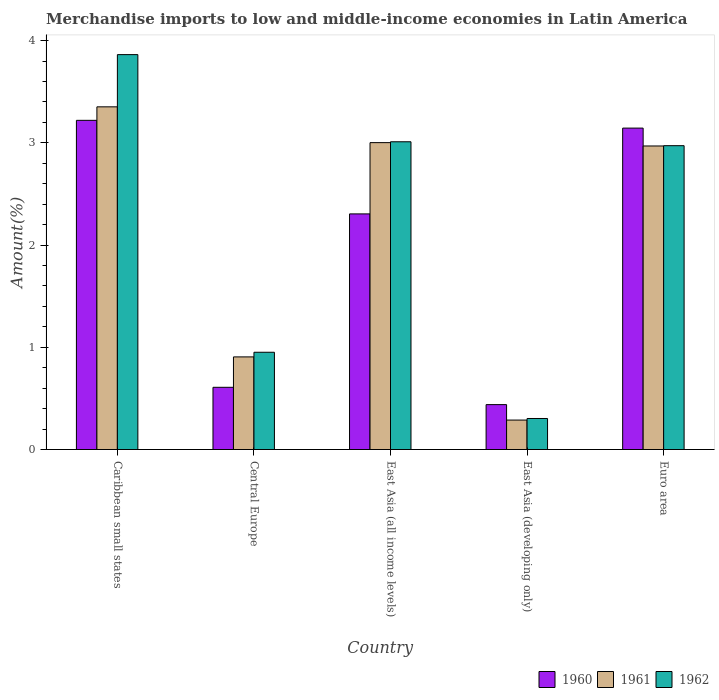How many groups of bars are there?
Keep it short and to the point. 5. Are the number of bars on each tick of the X-axis equal?
Your answer should be compact. Yes. In how many cases, is the number of bars for a given country not equal to the number of legend labels?
Your answer should be compact. 0. What is the percentage of amount earned from merchandise imports in 1962 in East Asia (all income levels)?
Offer a terse response. 3.01. Across all countries, what is the maximum percentage of amount earned from merchandise imports in 1962?
Ensure brevity in your answer.  3.86. Across all countries, what is the minimum percentage of amount earned from merchandise imports in 1960?
Provide a short and direct response. 0.44. In which country was the percentage of amount earned from merchandise imports in 1961 maximum?
Keep it short and to the point. Caribbean small states. In which country was the percentage of amount earned from merchandise imports in 1960 minimum?
Your answer should be compact. East Asia (developing only). What is the total percentage of amount earned from merchandise imports in 1960 in the graph?
Provide a short and direct response. 9.72. What is the difference between the percentage of amount earned from merchandise imports in 1960 in Central Europe and that in East Asia (all income levels)?
Offer a terse response. -1.7. What is the difference between the percentage of amount earned from merchandise imports in 1962 in Central Europe and the percentage of amount earned from merchandise imports in 1961 in Caribbean small states?
Provide a short and direct response. -2.4. What is the average percentage of amount earned from merchandise imports in 1960 per country?
Offer a very short reply. 1.94. What is the difference between the percentage of amount earned from merchandise imports of/in 1962 and percentage of amount earned from merchandise imports of/in 1961 in Central Europe?
Your response must be concise. 0.05. In how many countries, is the percentage of amount earned from merchandise imports in 1960 greater than 2.2 %?
Your response must be concise. 3. What is the ratio of the percentage of amount earned from merchandise imports in 1960 in Central Europe to that in East Asia (all income levels)?
Provide a succinct answer. 0.26. What is the difference between the highest and the second highest percentage of amount earned from merchandise imports in 1962?
Offer a terse response. 0.04. What is the difference between the highest and the lowest percentage of amount earned from merchandise imports in 1960?
Provide a short and direct response. 2.78. Is the sum of the percentage of amount earned from merchandise imports in 1962 in Caribbean small states and East Asia (all income levels) greater than the maximum percentage of amount earned from merchandise imports in 1961 across all countries?
Offer a very short reply. Yes. What does the 3rd bar from the right in Central Europe represents?
Give a very brief answer. 1960. Is it the case that in every country, the sum of the percentage of amount earned from merchandise imports in 1961 and percentage of amount earned from merchandise imports in 1962 is greater than the percentage of amount earned from merchandise imports in 1960?
Your answer should be compact. Yes. How many bars are there?
Offer a terse response. 15. Are all the bars in the graph horizontal?
Your response must be concise. No. How many countries are there in the graph?
Your answer should be very brief. 5. What is the difference between two consecutive major ticks on the Y-axis?
Provide a succinct answer. 1. Are the values on the major ticks of Y-axis written in scientific E-notation?
Provide a short and direct response. No. Does the graph contain any zero values?
Ensure brevity in your answer.  No. Does the graph contain grids?
Make the answer very short. No. What is the title of the graph?
Ensure brevity in your answer.  Merchandise imports to low and middle-income economies in Latin America. Does "1976" appear as one of the legend labels in the graph?
Make the answer very short. No. What is the label or title of the X-axis?
Give a very brief answer. Country. What is the label or title of the Y-axis?
Your answer should be very brief. Amount(%). What is the Amount(%) in 1960 in Caribbean small states?
Make the answer very short. 3.22. What is the Amount(%) in 1961 in Caribbean small states?
Offer a very short reply. 3.35. What is the Amount(%) in 1962 in Caribbean small states?
Your answer should be very brief. 3.86. What is the Amount(%) in 1960 in Central Europe?
Provide a succinct answer. 0.61. What is the Amount(%) of 1961 in Central Europe?
Give a very brief answer. 0.91. What is the Amount(%) of 1962 in Central Europe?
Your response must be concise. 0.95. What is the Amount(%) of 1960 in East Asia (all income levels)?
Provide a short and direct response. 2.31. What is the Amount(%) of 1961 in East Asia (all income levels)?
Your answer should be very brief. 3. What is the Amount(%) in 1962 in East Asia (all income levels)?
Your answer should be very brief. 3.01. What is the Amount(%) of 1960 in East Asia (developing only)?
Give a very brief answer. 0.44. What is the Amount(%) of 1961 in East Asia (developing only)?
Give a very brief answer. 0.29. What is the Amount(%) of 1962 in East Asia (developing only)?
Your answer should be compact. 0.3. What is the Amount(%) in 1960 in Euro area?
Offer a very short reply. 3.14. What is the Amount(%) in 1961 in Euro area?
Your answer should be compact. 2.97. What is the Amount(%) in 1962 in Euro area?
Give a very brief answer. 2.97. Across all countries, what is the maximum Amount(%) in 1960?
Give a very brief answer. 3.22. Across all countries, what is the maximum Amount(%) in 1961?
Your answer should be very brief. 3.35. Across all countries, what is the maximum Amount(%) of 1962?
Your response must be concise. 3.86. Across all countries, what is the minimum Amount(%) in 1960?
Provide a succinct answer. 0.44. Across all countries, what is the minimum Amount(%) in 1961?
Ensure brevity in your answer.  0.29. Across all countries, what is the minimum Amount(%) of 1962?
Provide a short and direct response. 0.3. What is the total Amount(%) in 1960 in the graph?
Ensure brevity in your answer.  9.72. What is the total Amount(%) of 1961 in the graph?
Offer a terse response. 10.52. What is the total Amount(%) of 1962 in the graph?
Give a very brief answer. 11.1. What is the difference between the Amount(%) in 1960 in Caribbean small states and that in Central Europe?
Keep it short and to the point. 2.61. What is the difference between the Amount(%) of 1961 in Caribbean small states and that in Central Europe?
Your answer should be very brief. 2.45. What is the difference between the Amount(%) of 1962 in Caribbean small states and that in Central Europe?
Your answer should be compact. 2.91. What is the difference between the Amount(%) in 1960 in Caribbean small states and that in East Asia (all income levels)?
Keep it short and to the point. 0.92. What is the difference between the Amount(%) in 1961 in Caribbean small states and that in East Asia (all income levels)?
Make the answer very short. 0.35. What is the difference between the Amount(%) of 1962 in Caribbean small states and that in East Asia (all income levels)?
Your answer should be compact. 0.85. What is the difference between the Amount(%) of 1960 in Caribbean small states and that in East Asia (developing only)?
Make the answer very short. 2.78. What is the difference between the Amount(%) of 1961 in Caribbean small states and that in East Asia (developing only)?
Provide a succinct answer. 3.06. What is the difference between the Amount(%) of 1962 in Caribbean small states and that in East Asia (developing only)?
Ensure brevity in your answer.  3.56. What is the difference between the Amount(%) of 1960 in Caribbean small states and that in Euro area?
Give a very brief answer. 0.08. What is the difference between the Amount(%) in 1961 in Caribbean small states and that in Euro area?
Your response must be concise. 0.38. What is the difference between the Amount(%) of 1962 in Caribbean small states and that in Euro area?
Keep it short and to the point. 0.89. What is the difference between the Amount(%) of 1960 in Central Europe and that in East Asia (all income levels)?
Provide a succinct answer. -1.7. What is the difference between the Amount(%) of 1961 in Central Europe and that in East Asia (all income levels)?
Make the answer very short. -2.1. What is the difference between the Amount(%) of 1962 in Central Europe and that in East Asia (all income levels)?
Make the answer very short. -2.06. What is the difference between the Amount(%) in 1960 in Central Europe and that in East Asia (developing only)?
Give a very brief answer. 0.17. What is the difference between the Amount(%) in 1961 in Central Europe and that in East Asia (developing only)?
Your answer should be compact. 0.62. What is the difference between the Amount(%) in 1962 in Central Europe and that in East Asia (developing only)?
Ensure brevity in your answer.  0.65. What is the difference between the Amount(%) in 1960 in Central Europe and that in Euro area?
Give a very brief answer. -2.54. What is the difference between the Amount(%) of 1961 in Central Europe and that in Euro area?
Offer a terse response. -2.06. What is the difference between the Amount(%) of 1962 in Central Europe and that in Euro area?
Offer a terse response. -2.02. What is the difference between the Amount(%) in 1960 in East Asia (all income levels) and that in East Asia (developing only)?
Offer a terse response. 1.87. What is the difference between the Amount(%) of 1961 in East Asia (all income levels) and that in East Asia (developing only)?
Your answer should be very brief. 2.71. What is the difference between the Amount(%) in 1962 in East Asia (all income levels) and that in East Asia (developing only)?
Your answer should be compact. 2.71. What is the difference between the Amount(%) of 1960 in East Asia (all income levels) and that in Euro area?
Your answer should be very brief. -0.84. What is the difference between the Amount(%) of 1961 in East Asia (all income levels) and that in Euro area?
Provide a short and direct response. 0.03. What is the difference between the Amount(%) of 1962 in East Asia (all income levels) and that in Euro area?
Your response must be concise. 0.04. What is the difference between the Amount(%) in 1960 in East Asia (developing only) and that in Euro area?
Your answer should be compact. -2.71. What is the difference between the Amount(%) of 1961 in East Asia (developing only) and that in Euro area?
Keep it short and to the point. -2.68. What is the difference between the Amount(%) of 1962 in East Asia (developing only) and that in Euro area?
Give a very brief answer. -2.67. What is the difference between the Amount(%) of 1960 in Caribbean small states and the Amount(%) of 1961 in Central Europe?
Make the answer very short. 2.31. What is the difference between the Amount(%) of 1960 in Caribbean small states and the Amount(%) of 1962 in Central Europe?
Provide a succinct answer. 2.27. What is the difference between the Amount(%) in 1961 in Caribbean small states and the Amount(%) in 1962 in Central Europe?
Offer a very short reply. 2.4. What is the difference between the Amount(%) in 1960 in Caribbean small states and the Amount(%) in 1961 in East Asia (all income levels)?
Your answer should be very brief. 0.22. What is the difference between the Amount(%) of 1960 in Caribbean small states and the Amount(%) of 1962 in East Asia (all income levels)?
Give a very brief answer. 0.21. What is the difference between the Amount(%) of 1961 in Caribbean small states and the Amount(%) of 1962 in East Asia (all income levels)?
Provide a succinct answer. 0.34. What is the difference between the Amount(%) of 1960 in Caribbean small states and the Amount(%) of 1961 in East Asia (developing only)?
Provide a short and direct response. 2.93. What is the difference between the Amount(%) in 1960 in Caribbean small states and the Amount(%) in 1962 in East Asia (developing only)?
Provide a short and direct response. 2.92. What is the difference between the Amount(%) of 1961 in Caribbean small states and the Amount(%) of 1962 in East Asia (developing only)?
Provide a short and direct response. 3.05. What is the difference between the Amount(%) of 1960 in Caribbean small states and the Amount(%) of 1961 in Euro area?
Ensure brevity in your answer.  0.25. What is the difference between the Amount(%) of 1960 in Caribbean small states and the Amount(%) of 1962 in Euro area?
Ensure brevity in your answer.  0.25. What is the difference between the Amount(%) of 1961 in Caribbean small states and the Amount(%) of 1962 in Euro area?
Make the answer very short. 0.38. What is the difference between the Amount(%) of 1960 in Central Europe and the Amount(%) of 1961 in East Asia (all income levels)?
Ensure brevity in your answer.  -2.39. What is the difference between the Amount(%) in 1960 in Central Europe and the Amount(%) in 1962 in East Asia (all income levels)?
Ensure brevity in your answer.  -2.4. What is the difference between the Amount(%) in 1961 in Central Europe and the Amount(%) in 1962 in East Asia (all income levels)?
Offer a very short reply. -2.1. What is the difference between the Amount(%) in 1960 in Central Europe and the Amount(%) in 1961 in East Asia (developing only)?
Offer a very short reply. 0.32. What is the difference between the Amount(%) in 1960 in Central Europe and the Amount(%) in 1962 in East Asia (developing only)?
Keep it short and to the point. 0.31. What is the difference between the Amount(%) of 1961 in Central Europe and the Amount(%) of 1962 in East Asia (developing only)?
Offer a terse response. 0.6. What is the difference between the Amount(%) of 1960 in Central Europe and the Amount(%) of 1961 in Euro area?
Offer a terse response. -2.36. What is the difference between the Amount(%) of 1960 in Central Europe and the Amount(%) of 1962 in Euro area?
Ensure brevity in your answer.  -2.36. What is the difference between the Amount(%) of 1961 in Central Europe and the Amount(%) of 1962 in Euro area?
Provide a short and direct response. -2.07. What is the difference between the Amount(%) in 1960 in East Asia (all income levels) and the Amount(%) in 1961 in East Asia (developing only)?
Provide a succinct answer. 2.02. What is the difference between the Amount(%) in 1960 in East Asia (all income levels) and the Amount(%) in 1962 in East Asia (developing only)?
Keep it short and to the point. 2. What is the difference between the Amount(%) in 1961 in East Asia (all income levels) and the Amount(%) in 1962 in East Asia (developing only)?
Ensure brevity in your answer.  2.7. What is the difference between the Amount(%) of 1960 in East Asia (all income levels) and the Amount(%) of 1961 in Euro area?
Ensure brevity in your answer.  -0.66. What is the difference between the Amount(%) in 1960 in East Asia (all income levels) and the Amount(%) in 1962 in Euro area?
Give a very brief answer. -0.67. What is the difference between the Amount(%) of 1961 in East Asia (all income levels) and the Amount(%) of 1962 in Euro area?
Your answer should be compact. 0.03. What is the difference between the Amount(%) in 1960 in East Asia (developing only) and the Amount(%) in 1961 in Euro area?
Offer a terse response. -2.53. What is the difference between the Amount(%) of 1960 in East Asia (developing only) and the Amount(%) of 1962 in Euro area?
Your response must be concise. -2.53. What is the difference between the Amount(%) of 1961 in East Asia (developing only) and the Amount(%) of 1962 in Euro area?
Offer a terse response. -2.68. What is the average Amount(%) in 1960 per country?
Provide a short and direct response. 1.94. What is the average Amount(%) in 1961 per country?
Offer a terse response. 2.1. What is the average Amount(%) in 1962 per country?
Your answer should be compact. 2.22. What is the difference between the Amount(%) of 1960 and Amount(%) of 1961 in Caribbean small states?
Keep it short and to the point. -0.13. What is the difference between the Amount(%) in 1960 and Amount(%) in 1962 in Caribbean small states?
Offer a very short reply. -0.64. What is the difference between the Amount(%) in 1961 and Amount(%) in 1962 in Caribbean small states?
Your answer should be compact. -0.51. What is the difference between the Amount(%) in 1960 and Amount(%) in 1961 in Central Europe?
Provide a short and direct response. -0.3. What is the difference between the Amount(%) in 1960 and Amount(%) in 1962 in Central Europe?
Provide a succinct answer. -0.34. What is the difference between the Amount(%) of 1961 and Amount(%) of 1962 in Central Europe?
Offer a terse response. -0.05. What is the difference between the Amount(%) in 1960 and Amount(%) in 1961 in East Asia (all income levels)?
Your answer should be very brief. -0.7. What is the difference between the Amount(%) in 1960 and Amount(%) in 1962 in East Asia (all income levels)?
Offer a very short reply. -0.71. What is the difference between the Amount(%) in 1961 and Amount(%) in 1962 in East Asia (all income levels)?
Your response must be concise. -0.01. What is the difference between the Amount(%) in 1960 and Amount(%) in 1961 in East Asia (developing only)?
Provide a succinct answer. 0.15. What is the difference between the Amount(%) in 1960 and Amount(%) in 1962 in East Asia (developing only)?
Provide a succinct answer. 0.14. What is the difference between the Amount(%) of 1961 and Amount(%) of 1962 in East Asia (developing only)?
Your answer should be compact. -0.02. What is the difference between the Amount(%) of 1960 and Amount(%) of 1961 in Euro area?
Your answer should be very brief. 0.17. What is the difference between the Amount(%) in 1960 and Amount(%) in 1962 in Euro area?
Make the answer very short. 0.17. What is the difference between the Amount(%) of 1961 and Amount(%) of 1962 in Euro area?
Your answer should be compact. -0. What is the ratio of the Amount(%) in 1960 in Caribbean small states to that in Central Europe?
Your answer should be compact. 5.29. What is the ratio of the Amount(%) of 1961 in Caribbean small states to that in Central Europe?
Your response must be concise. 3.7. What is the ratio of the Amount(%) of 1962 in Caribbean small states to that in Central Europe?
Provide a succinct answer. 4.06. What is the ratio of the Amount(%) of 1960 in Caribbean small states to that in East Asia (all income levels)?
Your response must be concise. 1.4. What is the ratio of the Amount(%) of 1961 in Caribbean small states to that in East Asia (all income levels)?
Offer a very short reply. 1.12. What is the ratio of the Amount(%) in 1962 in Caribbean small states to that in East Asia (all income levels)?
Ensure brevity in your answer.  1.28. What is the ratio of the Amount(%) in 1960 in Caribbean small states to that in East Asia (developing only)?
Your answer should be compact. 7.33. What is the ratio of the Amount(%) of 1961 in Caribbean small states to that in East Asia (developing only)?
Keep it short and to the point. 11.63. What is the ratio of the Amount(%) of 1962 in Caribbean small states to that in East Asia (developing only)?
Ensure brevity in your answer.  12.73. What is the ratio of the Amount(%) of 1960 in Caribbean small states to that in Euro area?
Provide a short and direct response. 1.02. What is the ratio of the Amount(%) of 1961 in Caribbean small states to that in Euro area?
Provide a succinct answer. 1.13. What is the ratio of the Amount(%) of 1962 in Caribbean small states to that in Euro area?
Your answer should be compact. 1.3. What is the ratio of the Amount(%) in 1960 in Central Europe to that in East Asia (all income levels)?
Offer a very short reply. 0.26. What is the ratio of the Amount(%) in 1961 in Central Europe to that in East Asia (all income levels)?
Make the answer very short. 0.3. What is the ratio of the Amount(%) in 1962 in Central Europe to that in East Asia (all income levels)?
Ensure brevity in your answer.  0.32. What is the ratio of the Amount(%) of 1960 in Central Europe to that in East Asia (developing only)?
Your answer should be compact. 1.39. What is the ratio of the Amount(%) in 1961 in Central Europe to that in East Asia (developing only)?
Your answer should be very brief. 3.14. What is the ratio of the Amount(%) of 1962 in Central Europe to that in East Asia (developing only)?
Ensure brevity in your answer.  3.13. What is the ratio of the Amount(%) in 1960 in Central Europe to that in Euro area?
Give a very brief answer. 0.19. What is the ratio of the Amount(%) in 1961 in Central Europe to that in Euro area?
Make the answer very short. 0.31. What is the ratio of the Amount(%) of 1962 in Central Europe to that in Euro area?
Provide a succinct answer. 0.32. What is the ratio of the Amount(%) in 1960 in East Asia (all income levels) to that in East Asia (developing only)?
Your answer should be very brief. 5.25. What is the ratio of the Amount(%) of 1961 in East Asia (all income levels) to that in East Asia (developing only)?
Give a very brief answer. 10.42. What is the ratio of the Amount(%) of 1962 in East Asia (all income levels) to that in East Asia (developing only)?
Provide a short and direct response. 9.92. What is the ratio of the Amount(%) of 1960 in East Asia (all income levels) to that in Euro area?
Offer a very short reply. 0.73. What is the ratio of the Amount(%) of 1961 in East Asia (all income levels) to that in Euro area?
Your response must be concise. 1.01. What is the ratio of the Amount(%) of 1962 in East Asia (all income levels) to that in Euro area?
Give a very brief answer. 1.01. What is the ratio of the Amount(%) in 1960 in East Asia (developing only) to that in Euro area?
Your answer should be very brief. 0.14. What is the ratio of the Amount(%) of 1961 in East Asia (developing only) to that in Euro area?
Your answer should be very brief. 0.1. What is the ratio of the Amount(%) in 1962 in East Asia (developing only) to that in Euro area?
Offer a very short reply. 0.1. What is the difference between the highest and the second highest Amount(%) of 1960?
Make the answer very short. 0.08. What is the difference between the highest and the second highest Amount(%) of 1961?
Provide a short and direct response. 0.35. What is the difference between the highest and the second highest Amount(%) in 1962?
Keep it short and to the point. 0.85. What is the difference between the highest and the lowest Amount(%) of 1960?
Provide a succinct answer. 2.78. What is the difference between the highest and the lowest Amount(%) in 1961?
Offer a terse response. 3.06. What is the difference between the highest and the lowest Amount(%) in 1962?
Provide a succinct answer. 3.56. 